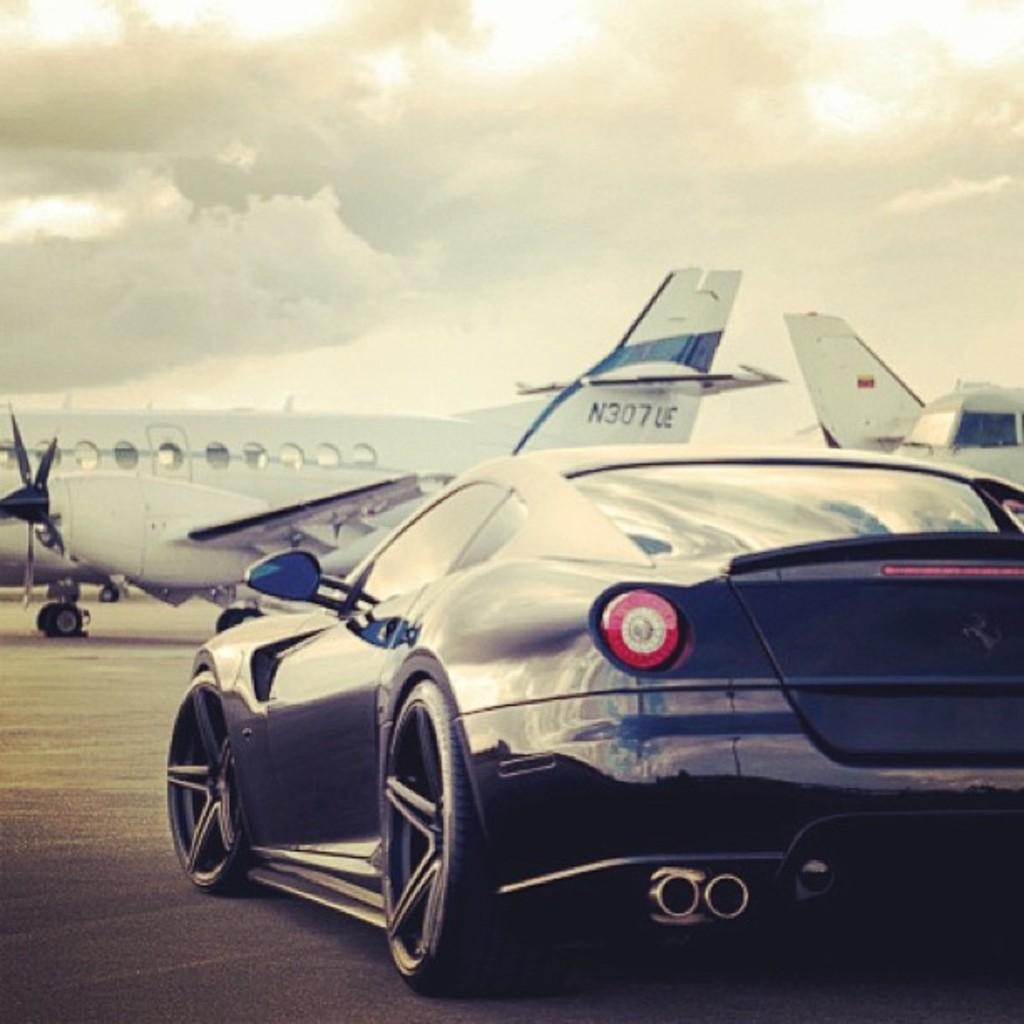Provide a one-sentence caption for the provided image. A sports car is shown with jet N307 UE in the background. 